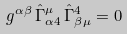Convert formula to latex. <formula><loc_0><loc_0><loc_500><loc_500>g ^ { \alpha \beta } \, { \hat { \Gamma } } ^ { \mu } _ { \alpha 4 } \, { \hat { \Gamma } } ^ { 4 } _ { \beta \mu } = 0</formula> 